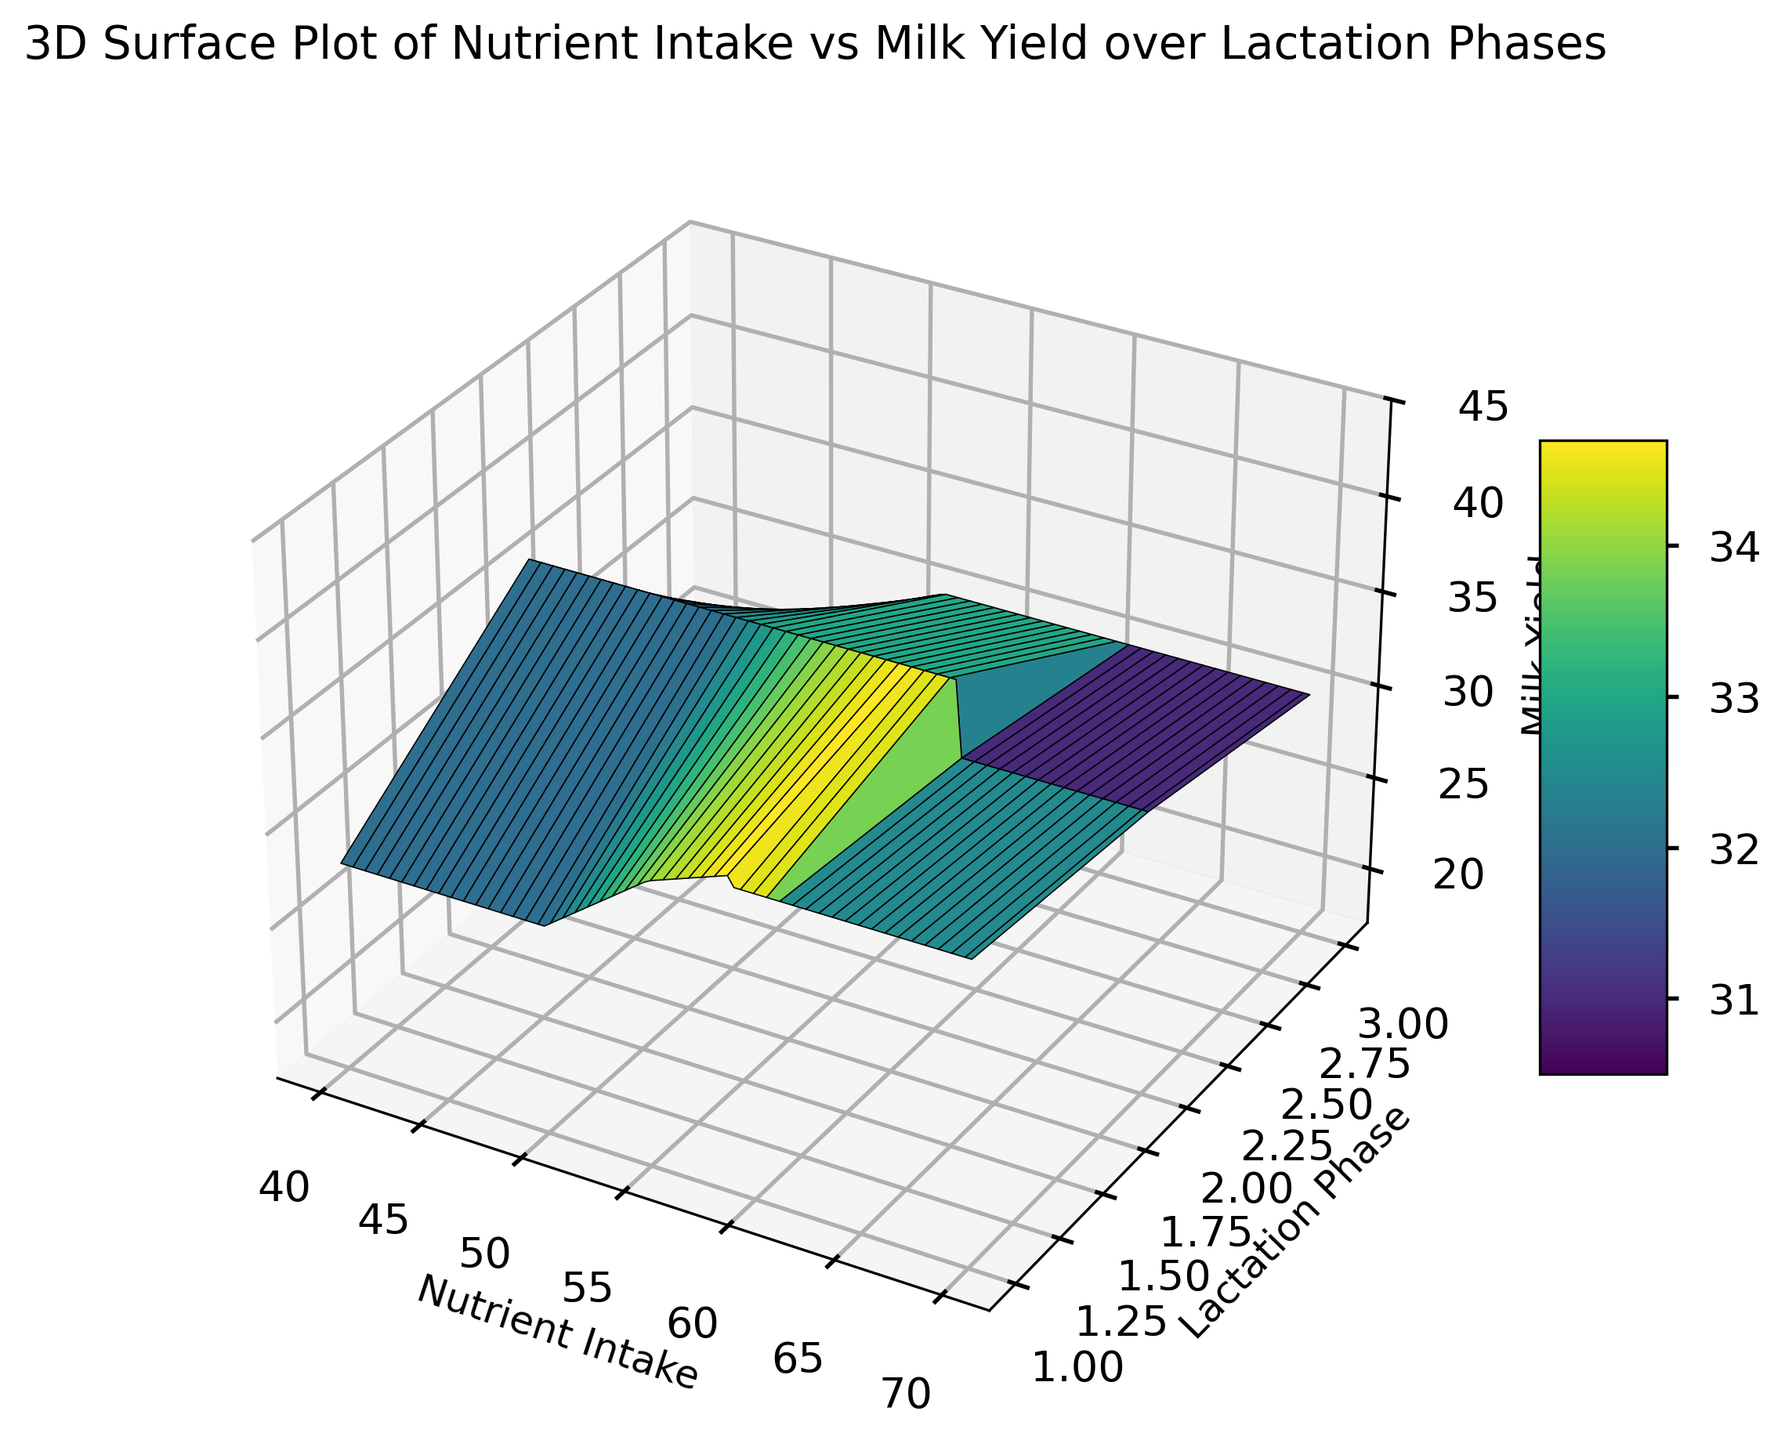Which lactation phase shows the highest overall milk yield? By observing the surface plot, the peak points of the surfaces corresponding to each lactation phase can be compared. The second lactation phase consistently reaches higher milk yields compared to phases one and three.
Answer: Phase 2 How does milk yield change with nutrient intake in lactation phase 1? In lactation phase 1, the plot shows an increasing trend in milk yield as nutrient intake increases. This trend can be seen by the upward slope of the surface in phase 1.
Answer: Increases Comparing lactation phases, which phase shows the most significant drop in milk yield as nutrient intake decreases? By examining the slopes of the surfaces across different phases, phase 3 shows a more significant decline in milk yield as nutrient intake decreases compared to phases 1 and 2.
Answer: Phase 3 What is the approximate milk yield when nutrient intake is 60 for lactation phase 2? By locating the point where nutrient intake is 60 on the X-axis and following it to the surface corresponding to phase 2, the approximate milk yield can be determined.
Answer: 38 Which lactation phase has the steepest gradient in milk yield relative to nutrient intake? By comparing the steepness of the plotted surfaces for each lactation phase, it can be observed that lactation phase 3 exhibits the steepest gradient. This indicates a more rapid change in milk yield with varying nutrient intakes.
Answer: Phase 3 In lactation phase 3, what is the trend in milk yield as nutrient intake goes from 50 to 43? By observing the plot for phase 3, it is clear that milk yield decreases as nutrient intake decreases from 50 to 43. This is reflected by the downward slope of the surface in this range.
Answer: Decreases What is the visual color characteristic of the highest milk yield region in the plot? The highest milk yield regions in the plot are associated with lighter colors, typically green-yellow, indicating higher values as per the color scale.
Answer: Lighter green-yellow Comparing nutrient intake of 50 units, which lactation phase demonstrates the lowest milk yield? By examining the surfaces at a nutrient intake of 50 units, lactation phase 3 shows the lowest milk yield as compared to phases 1 and 2.
Answer: Phase 3 Estimate the average milk yield for lactation phase 2 with nutrient intakes between 60 and 70. Locate the values of milk yield in lactation phase 2 between nutrient intakes of 60 and 70, then average these values. The milk yields are approximately 38, 37, 40, and 39. The average is (38 + 37 + 40 + 39) / 4 = 38.5
Answer: 38.5 